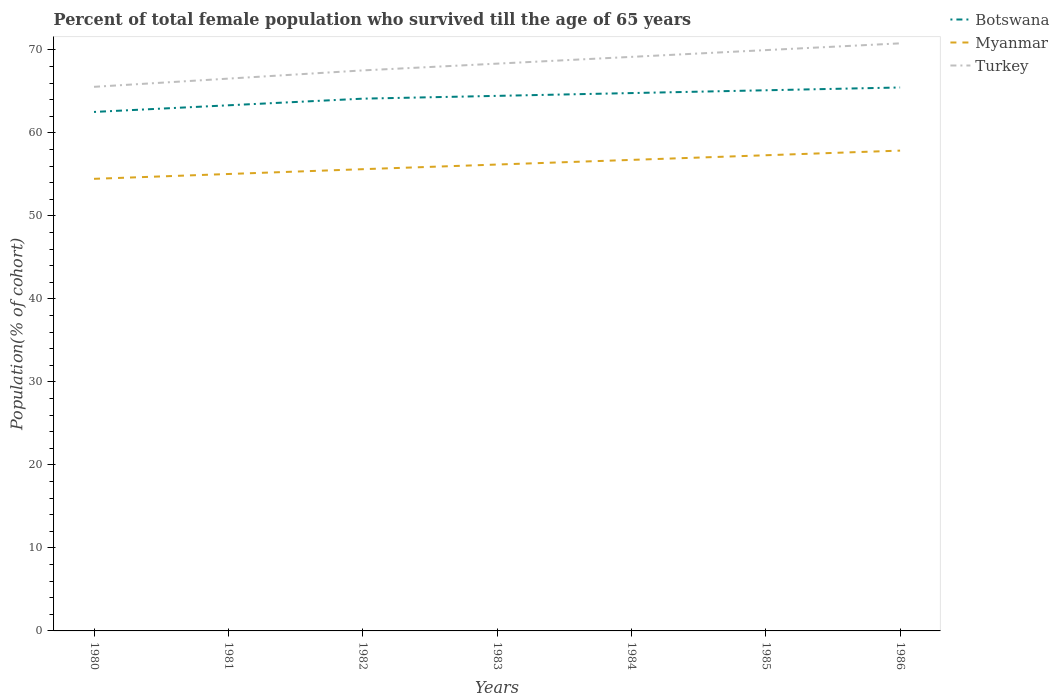Does the line corresponding to Myanmar intersect with the line corresponding to Turkey?
Give a very brief answer. No. Is the number of lines equal to the number of legend labels?
Your response must be concise. Yes. Across all years, what is the maximum percentage of total female population who survived till the age of 65 years in Botswana?
Keep it short and to the point. 62.54. In which year was the percentage of total female population who survived till the age of 65 years in Botswana maximum?
Your response must be concise. 1980. What is the total percentage of total female population who survived till the age of 65 years in Myanmar in the graph?
Your answer should be compact. -1.68. What is the difference between the highest and the second highest percentage of total female population who survived till the age of 65 years in Turkey?
Your answer should be compact. 5.24. What is the difference between the highest and the lowest percentage of total female population who survived till the age of 65 years in Turkey?
Keep it short and to the point. 4. Is the percentage of total female population who survived till the age of 65 years in Turkey strictly greater than the percentage of total female population who survived till the age of 65 years in Botswana over the years?
Offer a terse response. No. Are the values on the major ticks of Y-axis written in scientific E-notation?
Make the answer very short. No. Does the graph contain grids?
Make the answer very short. No. Where does the legend appear in the graph?
Your answer should be very brief. Top right. How are the legend labels stacked?
Offer a very short reply. Vertical. What is the title of the graph?
Ensure brevity in your answer.  Percent of total female population who survived till the age of 65 years. What is the label or title of the X-axis?
Your answer should be compact. Years. What is the label or title of the Y-axis?
Your response must be concise. Population(% of cohort). What is the Population(% of cohort) in Botswana in 1980?
Ensure brevity in your answer.  62.54. What is the Population(% of cohort) in Myanmar in 1980?
Provide a succinct answer. 54.48. What is the Population(% of cohort) in Turkey in 1980?
Offer a terse response. 65.56. What is the Population(% of cohort) of Botswana in 1981?
Your answer should be compact. 63.34. What is the Population(% of cohort) in Myanmar in 1981?
Give a very brief answer. 55.06. What is the Population(% of cohort) of Turkey in 1981?
Provide a short and direct response. 66.55. What is the Population(% of cohort) of Botswana in 1982?
Make the answer very short. 64.14. What is the Population(% of cohort) of Myanmar in 1982?
Your answer should be compact. 55.64. What is the Population(% of cohort) in Turkey in 1982?
Your answer should be compact. 67.54. What is the Population(% of cohort) in Botswana in 1983?
Provide a short and direct response. 64.47. What is the Population(% of cohort) in Myanmar in 1983?
Keep it short and to the point. 56.2. What is the Population(% of cohort) in Turkey in 1983?
Provide a short and direct response. 68.36. What is the Population(% of cohort) in Botswana in 1984?
Provide a succinct answer. 64.81. What is the Population(% of cohort) in Myanmar in 1984?
Provide a short and direct response. 56.76. What is the Population(% of cohort) of Turkey in 1984?
Your answer should be very brief. 69.17. What is the Population(% of cohort) in Botswana in 1985?
Your answer should be compact. 65.15. What is the Population(% of cohort) of Myanmar in 1985?
Make the answer very short. 57.32. What is the Population(% of cohort) of Turkey in 1985?
Provide a succinct answer. 69.99. What is the Population(% of cohort) of Botswana in 1986?
Keep it short and to the point. 65.48. What is the Population(% of cohort) of Myanmar in 1986?
Offer a very short reply. 57.88. What is the Population(% of cohort) in Turkey in 1986?
Offer a terse response. 70.8. Across all years, what is the maximum Population(% of cohort) of Botswana?
Offer a terse response. 65.48. Across all years, what is the maximum Population(% of cohort) in Myanmar?
Provide a short and direct response. 57.88. Across all years, what is the maximum Population(% of cohort) of Turkey?
Keep it short and to the point. 70.8. Across all years, what is the minimum Population(% of cohort) of Botswana?
Offer a very short reply. 62.54. Across all years, what is the minimum Population(% of cohort) in Myanmar?
Keep it short and to the point. 54.48. Across all years, what is the minimum Population(% of cohort) in Turkey?
Your answer should be compact. 65.56. What is the total Population(% of cohort) of Botswana in the graph?
Provide a short and direct response. 449.91. What is the total Population(% of cohort) in Myanmar in the graph?
Your response must be concise. 393.31. What is the total Population(% of cohort) in Turkey in the graph?
Give a very brief answer. 477.96. What is the difference between the Population(% of cohort) in Botswana in 1980 and that in 1981?
Offer a very short reply. -0.8. What is the difference between the Population(% of cohort) of Myanmar in 1980 and that in 1981?
Your answer should be compact. -0.58. What is the difference between the Population(% of cohort) in Turkey in 1980 and that in 1981?
Offer a terse response. -0.99. What is the difference between the Population(% of cohort) of Botswana in 1980 and that in 1982?
Your answer should be compact. -1.6. What is the difference between the Population(% of cohort) of Myanmar in 1980 and that in 1982?
Your answer should be very brief. -1.16. What is the difference between the Population(% of cohort) in Turkey in 1980 and that in 1982?
Keep it short and to the point. -1.98. What is the difference between the Population(% of cohort) of Botswana in 1980 and that in 1983?
Offer a very short reply. -1.94. What is the difference between the Population(% of cohort) in Myanmar in 1980 and that in 1983?
Make the answer very short. -1.72. What is the difference between the Population(% of cohort) of Turkey in 1980 and that in 1983?
Your response must be concise. -2.79. What is the difference between the Population(% of cohort) in Botswana in 1980 and that in 1984?
Offer a terse response. -2.27. What is the difference between the Population(% of cohort) in Myanmar in 1980 and that in 1984?
Provide a succinct answer. -2.28. What is the difference between the Population(% of cohort) in Turkey in 1980 and that in 1984?
Offer a terse response. -3.61. What is the difference between the Population(% of cohort) of Botswana in 1980 and that in 1985?
Ensure brevity in your answer.  -2.61. What is the difference between the Population(% of cohort) in Myanmar in 1980 and that in 1985?
Make the answer very short. -2.84. What is the difference between the Population(% of cohort) in Turkey in 1980 and that in 1985?
Offer a very short reply. -4.42. What is the difference between the Population(% of cohort) in Botswana in 1980 and that in 1986?
Ensure brevity in your answer.  -2.95. What is the difference between the Population(% of cohort) in Myanmar in 1980 and that in 1986?
Your response must be concise. -3.4. What is the difference between the Population(% of cohort) of Turkey in 1980 and that in 1986?
Offer a very short reply. -5.24. What is the difference between the Population(% of cohort) in Botswana in 1981 and that in 1982?
Offer a very short reply. -0.8. What is the difference between the Population(% of cohort) in Myanmar in 1981 and that in 1982?
Your answer should be very brief. -0.58. What is the difference between the Population(% of cohort) of Turkey in 1981 and that in 1982?
Your answer should be compact. -0.99. What is the difference between the Population(% of cohort) of Botswana in 1981 and that in 1983?
Ensure brevity in your answer.  -1.14. What is the difference between the Population(% of cohort) of Myanmar in 1981 and that in 1983?
Offer a very short reply. -1.14. What is the difference between the Population(% of cohort) of Turkey in 1981 and that in 1983?
Provide a succinct answer. -1.8. What is the difference between the Population(% of cohort) in Botswana in 1981 and that in 1984?
Offer a very short reply. -1.47. What is the difference between the Population(% of cohort) of Myanmar in 1981 and that in 1984?
Provide a succinct answer. -1.7. What is the difference between the Population(% of cohort) in Turkey in 1981 and that in 1984?
Ensure brevity in your answer.  -2.62. What is the difference between the Population(% of cohort) of Botswana in 1981 and that in 1985?
Offer a terse response. -1.81. What is the difference between the Population(% of cohort) in Myanmar in 1981 and that in 1985?
Offer a terse response. -2.26. What is the difference between the Population(% of cohort) in Turkey in 1981 and that in 1985?
Your answer should be very brief. -3.43. What is the difference between the Population(% of cohort) of Botswana in 1981 and that in 1986?
Your response must be concise. -2.15. What is the difference between the Population(% of cohort) of Myanmar in 1981 and that in 1986?
Give a very brief answer. -2.82. What is the difference between the Population(% of cohort) of Turkey in 1981 and that in 1986?
Provide a short and direct response. -4.25. What is the difference between the Population(% of cohort) of Botswana in 1982 and that in 1983?
Keep it short and to the point. -0.34. What is the difference between the Population(% of cohort) in Myanmar in 1982 and that in 1983?
Ensure brevity in your answer.  -0.56. What is the difference between the Population(% of cohort) of Turkey in 1982 and that in 1983?
Give a very brief answer. -0.81. What is the difference between the Population(% of cohort) of Botswana in 1982 and that in 1984?
Your answer should be compact. -0.67. What is the difference between the Population(% of cohort) in Myanmar in 1982 and that in 1984?
Provide a short and direct response. -1.12. What is the difference between the Population(% of cohort) of Turkey in 1982 and that in 1984?
Offer a very short reply. -1.63. What is the difference between the Population(% of cohort) of Botswana in 1982 and that in 1985?
Your answer should be very brief. -1.01. What is the difference between the Population(% of cohort) of Myanmar in 1982 and that in 1985?
Offer a very short reply. -1.68. What is the difference between the Population(% of cohort) in Turkey in 1982 and that in 1985?
Give a very brief answer. -2.44. What is the difference between the Population(% of cohort) in Botswana in 1982 and that in 1986?
Your response must be concise. -1.35. What is the difference between the Population(% of cohort) in Myanmar in 1982 and that in 1986?
Your answer should be very brief. -2.24. What is the difference between the Population(% of cohort) in Turkey in 1982 and that in 1986?
Offer a very short reply. -3.26. What is the difference between the Population(% of cohort) of Botswana in 1983 and that in 1984?
Provide a succinct answer. -0.34. What is the difference between the Population(% of cohort) in Myanmar in 1983 and that in 1984?
Your answer should be compact. -0.56. What is the difference between the Population(% of cohort) of Turkey in 1983 and that in 1984?
Offer a very short reply. -0.81. What is the difference between the Population(% of cohort) of Botswana in 1983 and that in 1985?
Offer a very short reply. -0.67. What is the difference between the Population(% of cohort) in Myanmar in 1983 and that in 1985?
Offer a terse response. -1.12. What is the difference between the Population(% of cohort) in Turkey in 1983 and that in 1985?
Give a very brief answer. -1.63. What is the difference between the Population(% of cohort) in Botswana in 1983 and that in 1986?
Give a very brief answer. -1.01. What is the difference between the Population(% of cohort) in Myanmar in 1983 and that in 1986?
Offer a terse response. -1.68. What is the difference between the Population(% of cohort) of Turkey in 1983 and that in 1986?
Your response must be concise. -2.44. What is the difference between the Population(% of cohort) of Botswana in 1984 and that in 1985?
Offer a terse response. -0.34. What is the difference between the Population(% of cohort) of Myanmar in 1984 and that in 1985?
Offer a terse response. -0.56. What is the difference between the Population(% of cohort) in Turkey in 1984 and that in 1985?
Provide a succinct answer. -0.81. What is the difference between the Population(% of cohort) in Botswana in 1984 and that in 1986?
Offer a very short reply. -0.67. What is the difference between the Population(% of cohort) in Myanmar in 1984 and that in 1986?
Your answer should be very brief. -1.12. What is the difference between the Population(% of cohort) of Turkey in 1984 and that in 1986?
Your response must be concise. -1.63. What is the difference between the Population(% of cohort) in Botswana in 1985 and that in 1986?
Provide a short and direct response. -0.34. What is the difference between the Population(% of cohort) in Myanmar in 1985 and that in 1986?
Ensure brevity in your answer.  -0.56. What is the difference between the Population(% of cohort) in Turkey in 1985 and that in 1986?
Offer a terse response. -0.81. What is the difference between the Population(% of cohort) of Botswana in 1980 and the Population(% of cohort) of Myanmar in 1981?
Provide a short and direct response. 7.48. What is the difference between the Population(% of cohort) of Botswana in 1980 and the Population(% of cohort) of Turkey in 1981?
Ensure brevity in your answer.  -4.02. What is the difference between the Population(% of cohort) in Myanmar in 1980 and the Population(% of cohort) in Turkey in 1981?
Give a very brief answer. -12.08. What is the difference between the Population(% of cohort) of Botswana in 1980 and the Population(% of cohort) of Myanmar in 1982?
Keep it short and to the point. 6.9. What is the difference between the Population(% of cohort) in Botswana in 1980 and the Population(% of cohort) in Turkey in 1982?
Give a very brief answer. -5.01. What is the difference between the Population(% of cohort) in Myanmar in 1980 and the Population(% of cohort) in Turkey in 1982?
Offer a very short reply. -13.06. What is the difference between the Population(% of cohort) in Botswana in 1980 and the Population(% of cohort) in Myanmar in 1983?
Your answer should be compact. 6.34. What is the difference between the Population(% of cohort) of Botswana in 1980 and the Population(% of cohort) of Turkey in 1983?
Your answer should be very brief. -5.82. What is the difference between the Population(% of cohort) of Myanmar in 1980 and the Population(% of cohort) of Turkey in 1983?
Offer a very short reply. -13.88. What is the difference between the Population(% of cohort) of Botswana in 1980 and the Population(% of cohort) of Myanmar in 1984?
Give a very brief answer. 5.78. What is the difference between the Population(% of cohort) of Botswana in 1980 and the Population(% of cohort) of Turkey in 1984?
Provide a short and direct response. -6.63. What is the difference between the Population(% of cohort) of Myanmar in 1980 and the Population(% of cohort) of Turkey in 1984?
Keep it short and to the point. -14.69. What is the difference between the Population(% of cohort) in Botswana in 1980 and the Population(% of cohort) in Myanmar in 1985?
Give a very brief answer. 5.22. What is the difference between the Population(% of cohort) in Botswana in 1980 and the Population(% of cohort) in Turkey in 1985?
Ensure brevity in your answer.  -7.45. What is the difference between the Population(% of cohort) in Myanmar in 1980 and the Population(% of cohort) in Turkey in 1985?
Your answer should be compact. -15.51. What is the difference between the Population(% of cohort) in Botswana in 1980 and the Population(% of cohort) in Myanmar in 1986?
Ensure brevity in your answer.  4.66. What is the difference between the Population(% of cohort) in Botswana in 1980 and the Population(% of cohort) in Turkey in 1986?
Your response must be concise. -8.26. What is the difference between the Population(% of cohort) in Myanmar in 1980 and the Population(% of cohort) in Turkey in 1986?
Offer a terse response. -16.32. What is the difference between the Population(% of cohort) of Botswana in 1981 and the Population(% of cohort) of Myanmar in 1982?
Your response must be concise. 7.7. What is the difference between the Population(% of cohort) in Botswana in 1981 and the Population(% of cohort) in Turkey in 1982?
Ensure brevity in your answer.  -4.21. What is the difference between the Population(% of cohort) in Myanmar in 1981 and the Population(% of cohort) in Turkey in 1982?
Offer a very short reply. -12.48. What is the difference between the Population(% of cohort) of Botswana in 1981 and the Population(% of cohort) of Myanmar in 1983?
Offer a very short reply. 7.14. What is the difference between the Population(% of cohort) in Botswana in 1981 and the Population(% of cohort) in Turkey in 1983?
Your answer should be very brief. -5.02. What is the difference between the Population(% of cohort) of Myanmar in 1981 and the Population(% of cohort) of Turkey in 1983?
Ensure brevity in your answer.  -13.3. What is the difference between the Population(% of cohort) of Botswana in 1981 and the Population(% of cohort) of Myanmar in 1984?
Your answer should be compact. 6.58. What is the difference between the Population(% of cohort) in Botswana in 1981 and the Population(% of cohort) in Turkey in 1984?
Make the answer very short. -5.83. What is the difference between the Population(% of cohort) of Myanmar in 1981 and the Population(% of cohort) of Turkey in 1984?
Provide a succinct answer. -14.11. What is the difference between the Population(% of cohort) in Botswana in 1981 and the Population(% of cohort) in Myanmar in 1985?
Offer a very short reply. 6.02. What is the difference between the Population(% of cohort) in Botswana in 1981 and the Population(% of cohort) in Turkey in 1985?
Your answer should be compact. -6.65. What is the difference between the Population(% of cohort) in Myanmar in 1981 and the Population(% of cohort) in Turkey in 1985?
Your response must be concise. -14.93. What is the difference between the Population(% of cohort) in Botswana in 1981 and the Population(% of cohort) in Myanmar in 1986?
Your answer should be very brief. 5.46. What is the difference between the Population(% of cohort) of Botswana in 1981 and the Population(% of cohort) of Turkey in 1986?
Offer a very short reply. -7.46. What is the difference between the Population(% of cohort) of Myanmar in 1981 and the Population(% of cohort) of Turkey in 1986?
Offer a very short reply. -15.74. What is the difference between the Population(% of cohort) in Botswana in 1982 and the Population(% of cohort) in Myanmar in 1983?
Provide a succinct answer. 7.94. What is the difference between the Population(% of cohort) in Botswana in 1982 and the Population(% of cohort) in Turkey in 1983?
Your answer should be compact. -4.22. What is the difference between the Population(% of cohort) of Myanmar in 1982 and the Population(% of cohort) of Turkey in 1983?
Provide a short and direct response. -12.72. What is the difference between the Population(% of cohort) of Botswana in 1982 and the Population(% of cohort) of Myanmar in 1984?
Your answer should be very brief. 7.38. What is the difference between the Population(% of cohort) in Botswana in 1982 and the Population(% of cohort) in Turkey in 1984?
Give a very brief answer. -5.04. What is the difference between the Population(% of cohort) of Myanmar in 1982 and the Population(% of cohort) of Turkey in 1984?
Ensure brevity in your answer.  -13.53. What is the difference between the Population(% of cohort) in Botswana in 1982 and the Population(% of cohort) in Myanmar in 1985?
Ensure brevity in your answer.  6.82. What is the difference between the Population(% of cohort) in Botswana in 1982 and the Population(% of cohort) in Turkey in 1985?
Make the answer very short. -5.85. What is the difference between the Population(% of cohort) in Myanmar in 1982 and the Population(% of cohort) in Turkey in 1985?
Your response must be concise. -14.35. What is the difference between the Population(% of cohort) of Botswana in 1982 and the Population(% of cohort) of Myanmar in 1986?
Your response must be concise. 6.26. What is the difference between the Population(% of cohort) in Botswana in 1982 and the Population(% of cohort) in Turkey in 1986?
Ensure brevity in your answer.  -6.66. What is the difference between the Population(% of cohort) of Myanmar in 1982 and the Population(% of cohort) of Turkey in 1986?
Keep it short and to the point. -15.16. What is the difference between the Population(% of cohort) in Botswana in 1983 and the Population(% of cohort) in Myanmar in 1984?
Your answer should be compact. 7.72. What is the difference between the Population(% of cohort) in Botswana in 1983 and the Population(% of cohort) in Turkey in 1984?
Provide a short and direct response. -4.7. What is the difference between the Population(% of cohort) of Myanmar in 1983 and the Population(% of cohort) of Turkey in 1984?
Make the answer very short. -12.97. What is the difference between the Population(% of cohort) in Botswana in 1983 and the Population(% of cohort) in Myanmar in 1985?
Keep it short and to the point. 7.16. What is the difference between the Population(% of cohort) in Botswana in 1983 and the Population(% of cohort) in Turkey in 1985?
Make the answer very short. -5.51. What is the difference between the Population(% of cohort) in Myanmar in 1983 and the Population(% of cohort) in Turkey in 1985?
Give a very brief answer. -13.79. What is the difference between the Population(% of cohort) in Botswana in 1983 and the Population(% of cohort) in Myanmar in 1986?
Your answer should be very brief. 6.6. What is the difference between the Population(% of cohort) of Botswana in 1983 and the Population(% of cohort) of Turkey in 1986?
Provide a short and direct response. -6.33. What is the difference between the Population(% of cohort) in Myanmar in 1983 and the Population(% of cohort) in Turkey in 1986?
Provide a succinct answer. -14.6. What is the difference between the Population(% of cohort) of Botswana in 1984 and the Population(% of cohort) of Myanmar in 1985?
Make the answer very short. 7.49. What is the difference between the Population(% of cohort) of Botswana in 1984 and the Population(% of cohort) of Turkey in 1985?
Ensure brevity in your answer.  -5.18. What is the difference between the Population(% of cohort) of Myanmar in 1984 and the Population(% of cohort) of Turkey in 1985?
Your response must be concise. -13.23. What is the difference between the Population(% of cohort) of Botswana in 1984 and the Population(% of cohort) of Myanmar in 1986?
Offer a very short reply. 6.93. What is the difference between the Population(% of cohort) in Botswana in 1984 and the Population(% of cohort) in Turkey in 1986?
Your answer should be compact. -5.99. What is the difference between the Population(% of cohort) of Myanmar in 1984 and the Population(% of cohort) of Turkey in 1986?
Provide a succinct answer. -14.04. What is the difference between the Population(% of cohort) of Botswana in 1985 and the Population(% of cohort) of Myanmar in 1986?
Your response must be concise. 7.27. What is the difference between the Population(% of cohort) of Botswana in 1985 and the Population(% of cohort) of Turkey in 1986?
Give a very brief answer. -5.65. What is the difference between the Population(% of cohort) of Myanmar in 1985 and the Population(% of cohort) of Turkey in 1986?
Your answer should be compact. -13.48. What is the average Population(% of cohort) of Botswana per year?
Your answer should be compact. 64.27. What is the average Population(% of cohort) in Myanmar per year?
Your answer should be compact. 56.19. What is the average Population(% of cohort) of Turkey per year?
Make the answer very short. 68.28. In the year 1980, what is the difference between the Population(% of cohort) in Botswana and Population(% of cohort) in Myanmar?
Make the answer very short. 8.06. In the year 1980, what is the difference between the Population(% of cohort) of Botswana and Population(% of cohort) of Turkey?
Offer a very short reply. -3.03. In the year 1980, what is the difference between the Population(% of cohort) in Myanmar and Population(% of cohort) in Turkey?
Offer a very short reply. -11.09. In the year 1981, what is the difference between the Population(% of cohort) in Botswana and Population(% of cohort) in Myanmar?
Offer a very short reply. 8.28. In the year 1981, what is the difference between the Population(% of cohort) of Botswana and Population(% of cohort) of Turkey?
Keep it short and to the point. -3.22. In the year 1981, what is the difference between the Population(% of cohort) in Myanmar and Population(% of cohort) in Turkey?
Your response must be concise. -11.49. In the year 1982, what is the difference between the Population(% of cohort) in Botswana and Population(% of cohort) in Myanmar?
Ensure brevity in your answer.  8.5. In the year 1982, what is the difference between the Population(% of cohort) of Botswana and Population(% of cohort) of Turkey?
Your answer should be very brief. -3.41. In the year 1982, what is the difference between the Population(% of cohort) in Myanmar and Population(% of cohort) in Turkey?
Provide a succinct answer. -11.9. In the year 1983, what is the difference between the Population(% of cohort) of Botswana and Population(% of cohort) of Myanmar?
Provide a succinct answer. 8.27. In the year 1983, what is the difference between the Population(% of cohort) of Botswana and Population(% of cohort) of Turkey?
Provide a short and direct response. -3.88. In the year 1983, what is the difference between the Population(% of cohort) in Myanmar and Population(% of cohort) in Turkey?
Offer a terse response. -12.16. In the year 1984, what is the difference between the Population(% of cohort) in Botswana and Population(% of cohort) in Myanmar?
Your answer should be compact. 8.05. In the year 1984, what is the difference between the Population(% of cohort) of Botswana and Population(% of cohort) of Turkey?
Give a very brief answer. -4.36. In the year 1984, what is the difference between the Population(% of cohort) in Myanmar and Population(% of cohort) in Turkey?
Keep it short and to the point. -12.41. In the year 1985, what is the difference between the Population(% of cohort) in Botswana and Population(% of cohort) in Myanmar?
Ensure brevity in your answer.  7.83. In the year 1985, what is the difference between the Population(% of cohort) in Botswana and Population(% of cohort) in Turkey?
Offer a terse response. -4.84. In the year 1985, what is the difference between the Population(% of cohort) in Myanmar and Population(% of cohort) in Turkey?
Provide a succinct answer. -12.67. In the year 1986, what is the difference between the Population(% of cohort) of Botswana and Population(% of cohort) of Myanmar?
Provide a succinct answer. 7.61. In the year 1986, what is the difference between the Population(% of cohort) in Botswana and Population(% of cohort) in Turkey?
Keep it short and to the point. -5.32. In the year 1986, what is the difference between the Population(% of cohort) in Myanmar and Population(% of cohort) in Turkey?
Provide a succinct answer. -12.92. What is the ratio of the Population(% of cohort) in Botswana in 1980 to that in 1981?
Keep it short and to the point. 0.99. What is the ratio of the Population(% of cohort) of Turkey in 1980 to that in 1981?
Keep it short and to the point. 0.99. What is the ratio of the Population(% of cohort) in Botswana in 1980 to that in 1982?
Provide a short and direct response. 0.98. What is the ratio of the Population(% of cohort) of Myanmar in 1980 to that in 1982?
Make the answer very short. 0.98. What is the ratio of the Population(% of cohort) of Turkey in 1980 to that in 1982?
Ensure brevity in your answer.  0.97. What is the ratio of the Population(% of cohort) in Myanmar in 1980 to that in 1983?
Ensure brevity in your answer.  0.97. What is the ratio of the Population(% of cohort) in Turkey in 1980 to that in 1983?
Keep it short and to the point. 0.96. What is the ratio of the Population(% of cohort) of Botswana in 1980 to that in 1984?
Keep it short and to the point. 0.96. What is the ratio of the Population(% of cohort) of Myanmar in 1980 to that in 1984?
Provide a short and direct response. 0.96. What is the ratio of the Population(% of cohort) of Turkey in 1980 to that in 1984?
Your response must be concise. 0.95. What is the ratio of the Population(% of cohort) of Botswana in 1980 to that in 1985?
Offer a terse response. 0.96. What is the ratio of the Population(% of cohort) in Myanmar in 1980 to that in 1985?
Your response must be concise. 0.95. What is the ratio of the Population(% of cohort) of Turkey in 1980 to that in 1985?
Make the answer very short. 0.94. What is the ratio of the Population(% of cohort) of Botswana in 1980 to that in 1986?
Your response must be concise. 0.95. What is the ratio of the Population(% of cohort) of Myanmar in 1980 to that in 1986?
Your answer should be very brief. 0.94. What is the ratio of the Population(% of cohort) in Turkey in 1980 to that in 1986?
Make the answer very short. 0.93. What is the ratio of the Population(% of cohort) of Botswana in 1981 to that in 1982?
Keep it short and to the point. 0.99. What is the ratio of the Population(% of cohort) in Myanmar in 1981 to that in 1982?
Make the answer very short. 0.99. What is the ratio of the Population(% of cohort) in Botswana in 1981 to that in 1983?
Your answer should be very brief. 0.98. What is the ratio of the Population(% of cohort) of Myanmar in 1981 to that in 1983?
Keep it short and to the point. 0.98. What is the ratio of the Population(% of cohort) of Turkey in 1981 to that in 1983?
Make the answer very short. 0.97. What is the ratio of the Population(% of cohort) of Botswana in 1981 to that in 1984?
Make the answer very short. 0.98. What is the ratio of the Population(% of cohort) of Myanmar in 1981 to that in 1984?
Keep it short and to the point. 0.97. What is the ratio of the Population(% of cohort) of Turkey in 1981 to that in 1984?
Ensure brevity in your answer.  0.96. What is the ratio of the Population(% of cohort) in Botswana in 1981 to that in 1985?
Your answer should be compact. 0.97. What is the ratio of the Population(% of cohort) of Myanmar in 1981 to that in 1985?
Ensure brevity in your answer.  0.96. What is the ratio of the Population(% of cohort) in Turkey in 1981 to that in 1985?
Offer a terse response. 0.95. What is the ratio of the Population(% of cohort) in Botswana in 1981 to that in 1986?
Your answer should be very brief. 0.97. What is the ratio of the Population(% of cohort) of Myanmar in 1981 to that in 1986?
Provide a succinct answer. 0.95. What is the ratio of the Population(% of cohort) of Botswana in 1982 to that in 1984?
Your answer should be compact. 0.99. What is the ratio of the Population(% of cohort) of Myanmar in 1982 to that in 1984?
Your answer should be very brief. 0.98. What is the ratio of the Population(% of cohort) of Turkey in 1982 to that in 1984?
Provide a short and direct response. 0.98. What is the ratio of the Population(% of cohort) in Botswana in 1982 to that in 1985?
Provide a succinct answer. 0.98. What is the ratio of the Population(% of cohort) of Myanmar in 1982 to that in 1985?
Offer a very short reply. 0.97. What is the ratio of the Population(% of cohort) of Turkey in 1982 to that in 1985?
Provide a succinct answer. 0.97. What is the ratio of the Population(% of cohort) in Botswana in 1982 to that in 1986?
Offer a terse response. 0.98. What is the ratio of the Population(% of cohort) of Myanmar in 1982 to that in 1986?
Give a very brief answer. 0.96. What is the ratio of the Population(% of cohort) of Turkey in 1982 to that in 1986?
Provide a short and direct response. 0.95. What is the ratio of the Population(% of cohort) in Botswana in 1983 to that in 1984?
Provide a short and direct response. 0.99. What is the ratio of the Population(% of cohort) of Botswana in 1983 to that in 1985?
Your answer should be very brief. 0.99. What is the ratio of the Population(% of cohort) in Myanmar in 1983 to that in 1985?
Provide a succinct answer. 0.98. What is the ratio of the Population(% of cohort) of Turkey in 1983 to that in 1985?
Your answer should be compact. 0.98. What is the ratio of the Population(% of cohort) in Botswana in 1983 to that in 1986?
Your answer should be very brief. 0.98. What is the ratio of the Population(% of cohort) in Myanmar in 1983 to that in 1986?
Offer a terse response. 0.97. What is the ratio of the Population(% of cohort) in Turkey in 1983 to that in 1986?
Offer a very short reply. 0.97. What is the ratio of the Population(% of cohort) of Botswana in 1984 to that in 1985?
Offer a terse response. 0.99. What is the ratio of the Population(% of cohort) in Myanmar in 1984 to that in 1985?
Your response must be concise. 0.99. What is the ratio of the Population(% of cohort) in Turkey in 1984 to that in 1985?
Your answer should be compact. 0.99. What is the ratio of the Population(% of cohort) of Botswana in 1984 to that in 1986?
Make the answer very short. 0.99. What is the ratio of the Population(% of cohort) in Myanmar in 1984 to that in 1986?
Keep it short and to the point. 0.98. What is the ratio of the Population(% of cohort) of Turkey in 1984 to that in 1986?
Provide a succinct answer. 0.98. What is the ratio of the Population(% of cohort) in Botswana in 1985 to that in 1986?
Your response must be concise. 0.99. What is the ratio of the Population(% of cohort) in Myanmar in 1985 to that in 1986?
Offer a very short reply. 0.99. What is the difference between the highest and the second highest Population(% of cohort) in Botswana?
Make the answer very short. 0.34. What is the difference between the highest and the second highest Population(% of cohort) in Myanmar?
Your answer should be compact. 0.56. What is the difference between the highest and the second highest Population(% of cohort) of Turkey?
Your answer should be compact. 0.81. What is the difference between the highest and the lowest Population(% of cohort) in Botswana?
Make the answer very short. 2.95. What is the difference between the highest and the lowest Population(% of cohort) in Myanmar?
Your response must be concise. 3.4. What is the difference between the highest and the lowest Population(% of cohort) in Turkey?
Your answer should be compact. 5.24. 